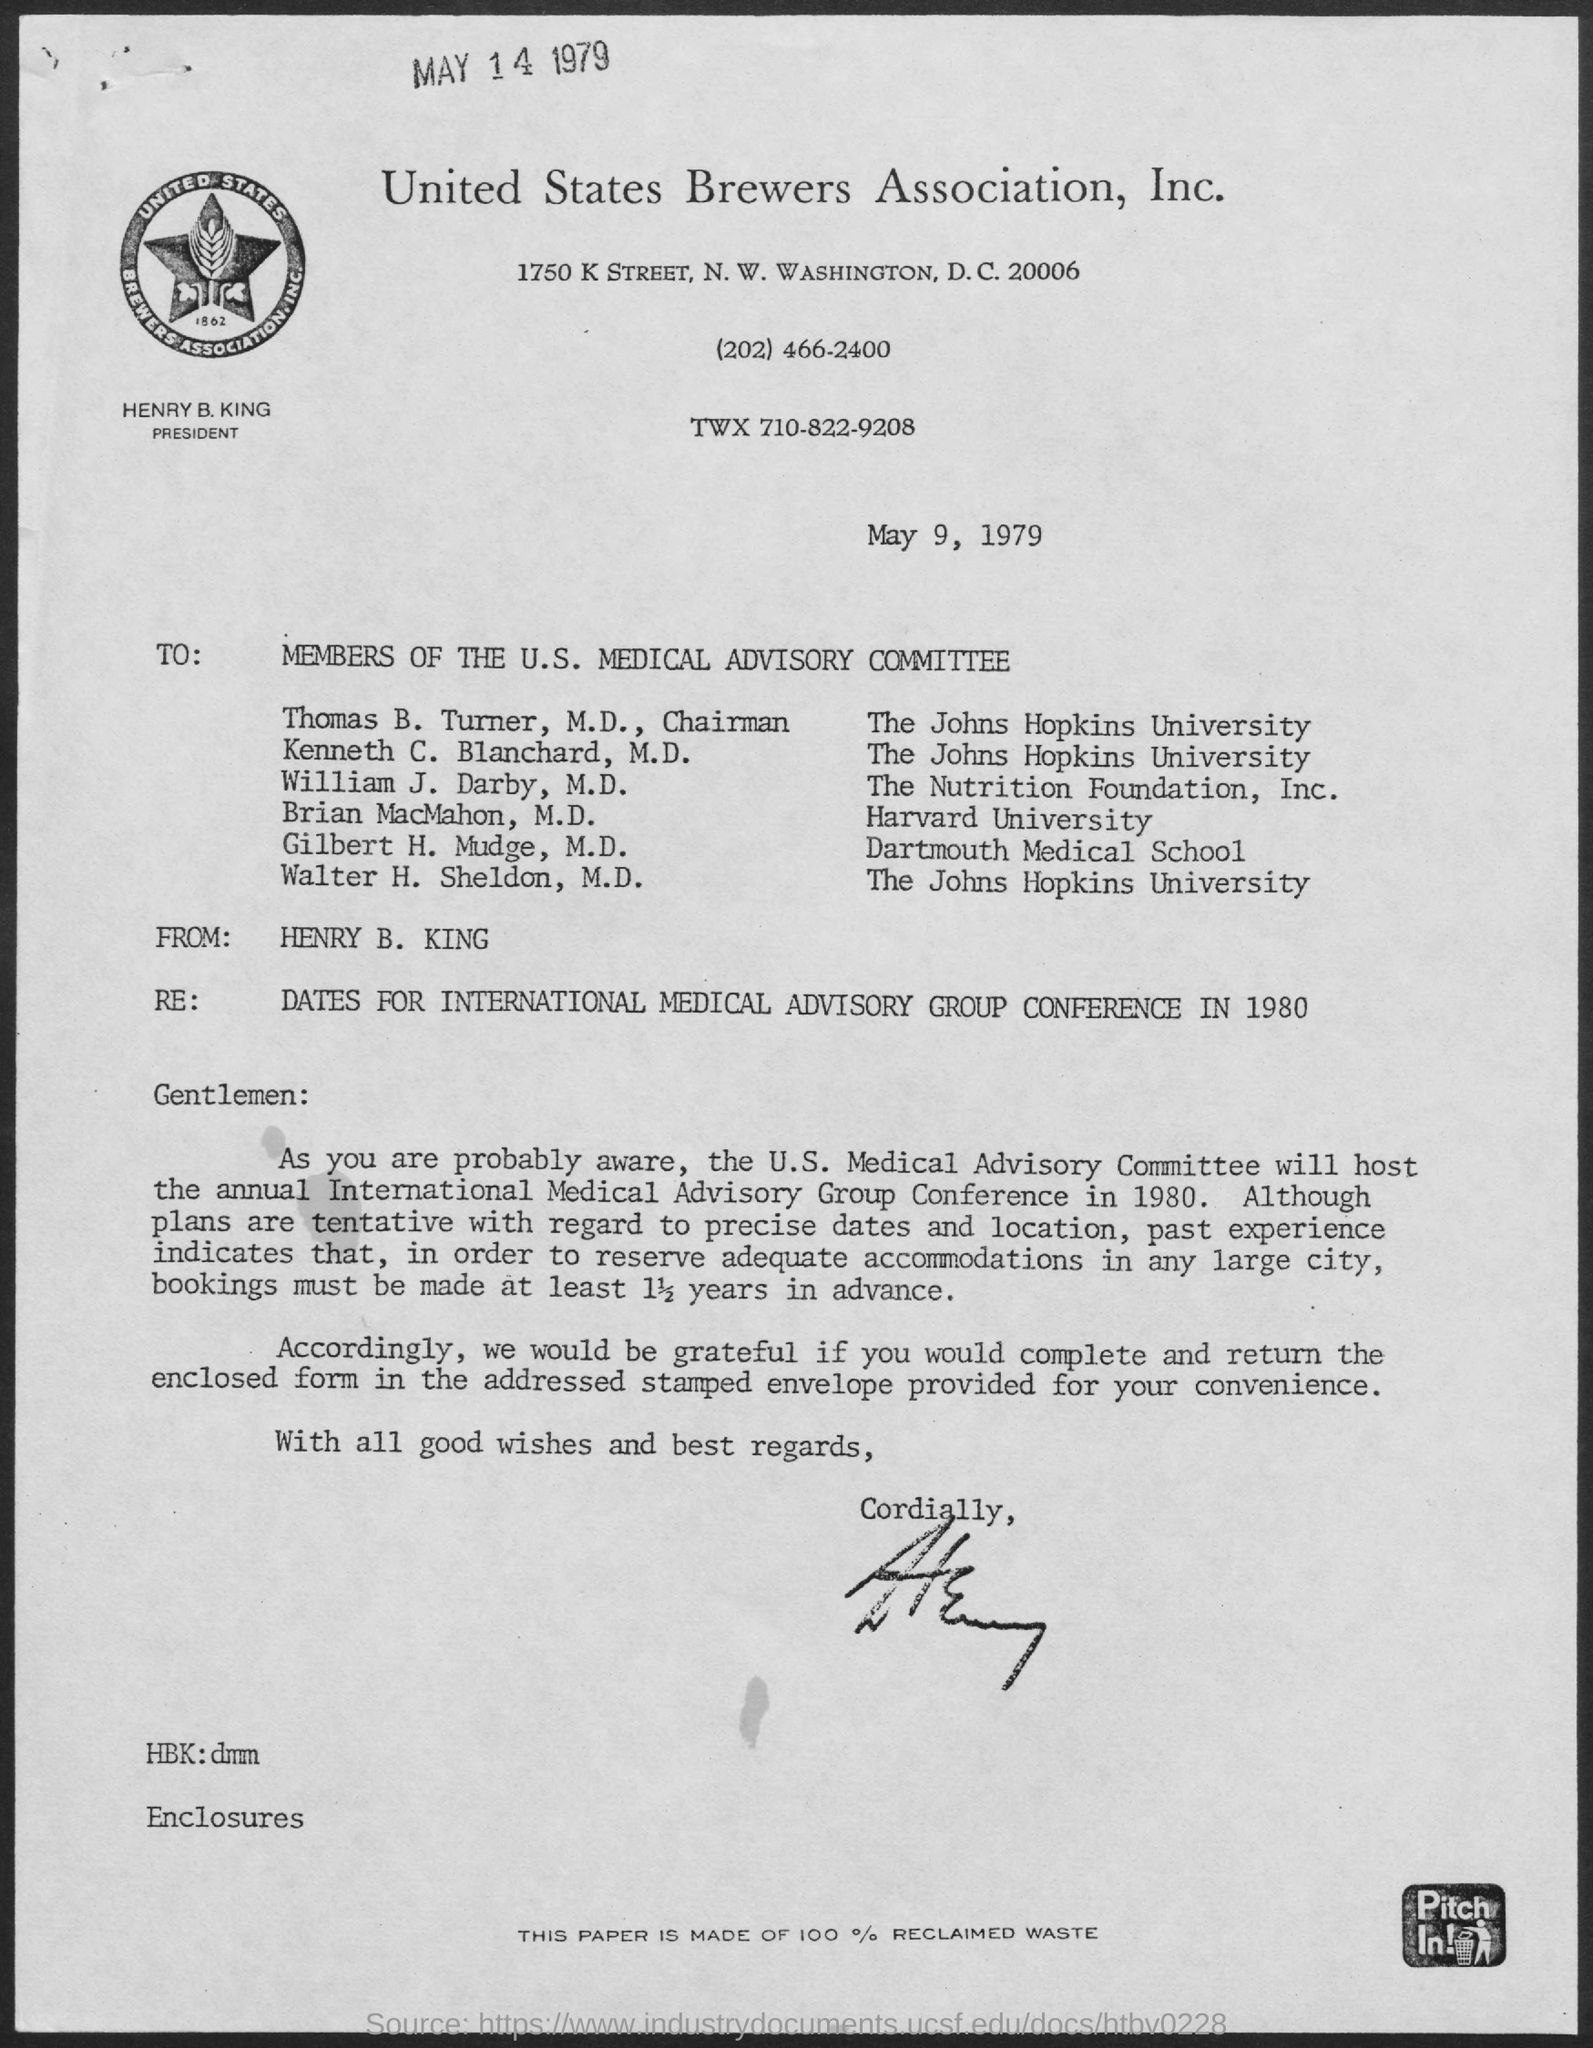Indicate a few pertinent items in this graphic. On May 9th, 1979, the date mentioned, occurred. The United States Brewer's Association, Inc. is a named association mentioned. The letter was written to the members of the U.S. Medical Advisory Committee. The date mentioned at the top of the page is May 14, 1979. The letter was received from Henry B. King. 